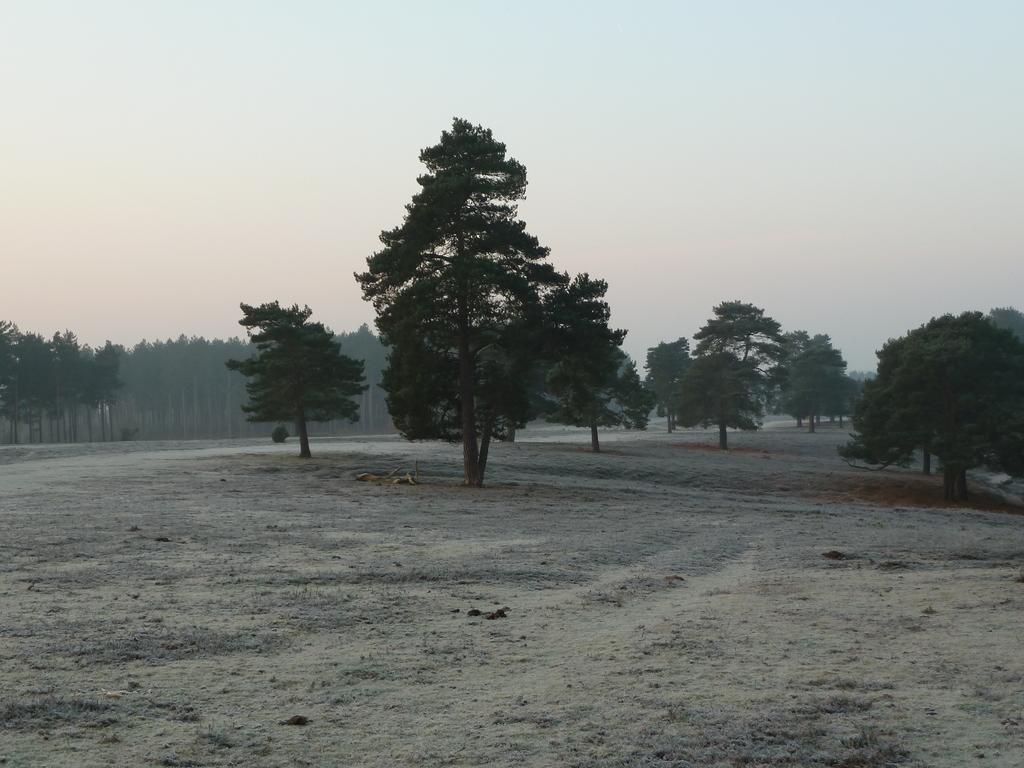Describe this image in one or two sentences. This is a black and white picture, there are trees on the background and above its sky. 